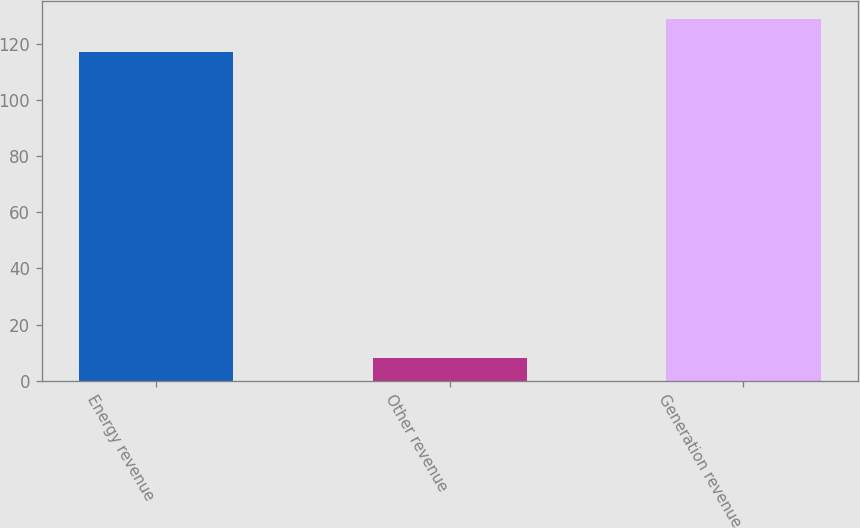<chart> <loc_0><loc_0><loc_500><loc_500><bar_chart><fcel>Energy revenue<fcel>Other revenue<fcel>Generation revenue<nl><fcel>117<fcel>8<fcel>128.7<nl></chart> 